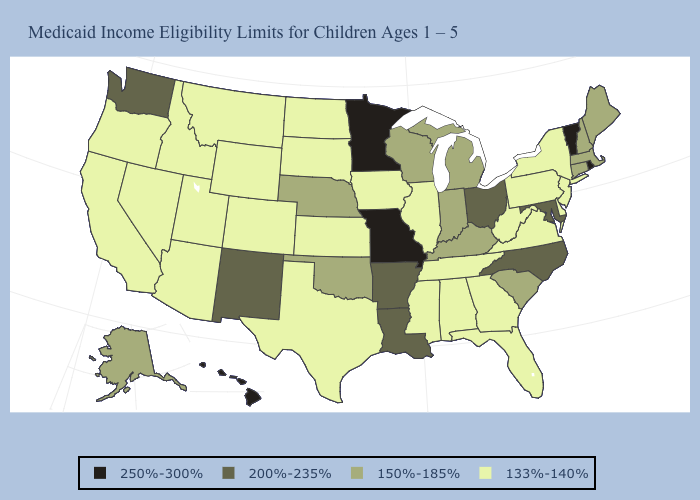Does Arizona have the lowest value in the USA?
Give a very brief answer. Yes. What is the lowest value in the USA?
Quick response, please. 133%-140%. What is the lowest value in the MidWest?
Give a very brief answer. 133%-140%. What is the highest value in the South ?
Write a very short answer. 200%-235%. What is the highest value in the West ?
Answer briefly. 250%-300%. Name the states that have a value in the range 150%-185%?
Keep it brief. Alaska, Connecticut, Indiana, Kentucky, Maine, Massachusetts, Michigan, Nebraska, New Hampshire, Oklahoma, South Carolina, Wisconsin. Name the states that have a value in the range 133%-140%?
Write a very short answer. Alabama, Arizona, California, Colorado, Delaware, Florida, Georgia, Idaho, Illinois, Iowa, Kansas, Mississippi, Montana, Nevada, New Jersey, New York, North Dakota, Oregon, Pennsylvania, South Dakota, Tennessee, Texas, Utah, Virginia, West Virginia, Wyoming. Name the states that have a value in the range 200%-235%?
Answer briefly. Arkansas, Louisiana, Maryland, New Mexico, North Carolina, Ohio, Washington. What is the value of Kansas?
Answer briefly. 133%-140%. Which states have the highest value in the USA?
Quick response, please. Hawaii, Minnesota, Missouri, Rhode Island, Vermont. What is the lowest value in states that border New Mexico?
Be succinct. 133%-140%. What is the value of Idaho?
Short answer required. 133%-140%. Which states have the lowest value in the MidWest?
Give a very brief answer. Illinois, Iowa, Kansas, North Dakota, South Dakota. What is the value of Georgia?
Write a very short answer. 133%-140%. 